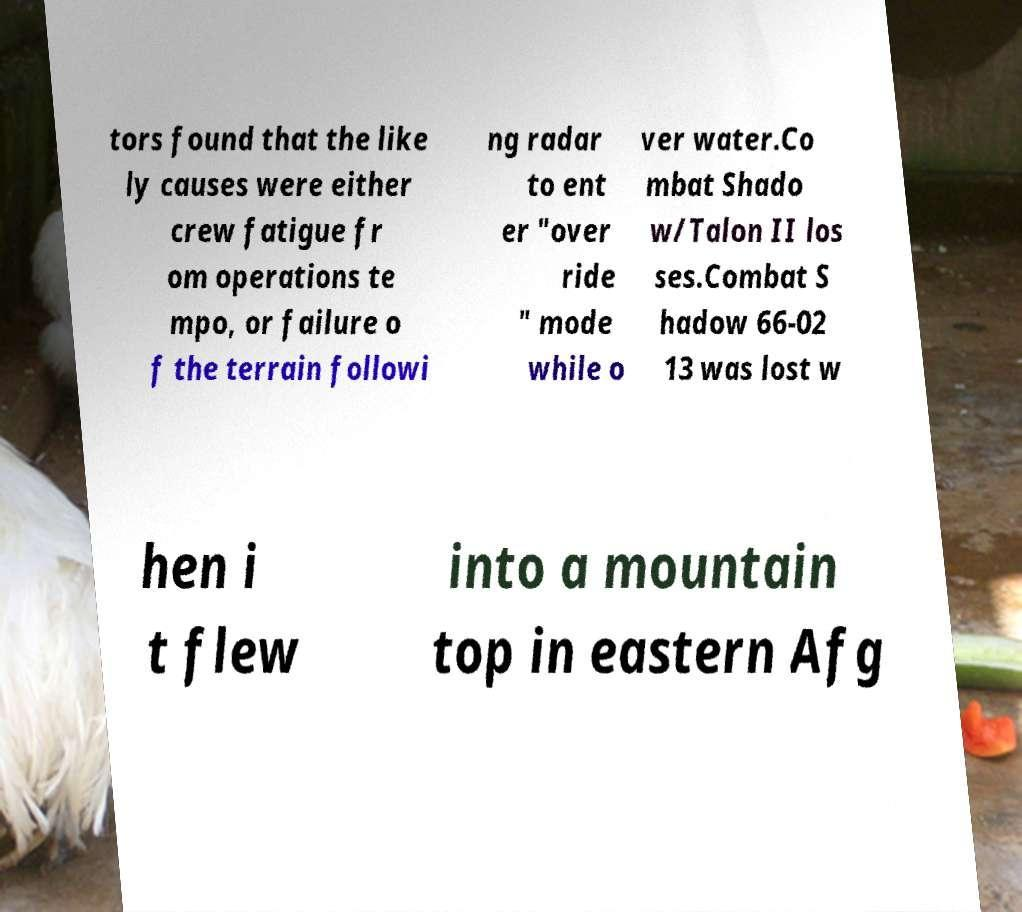I need the written content from this picture converted into text. Can you do that? tors found that the like ly causes were either crew fatigue fr om operations te mpo, or failure o f the terrain followi ng radar to ent er "over ride " mode while o ver water.Co mbat Shado w/Talon II los ses.Combat S hadow 66-02 13 was lost w hen i t flew into a mountain top in eastern Afg 